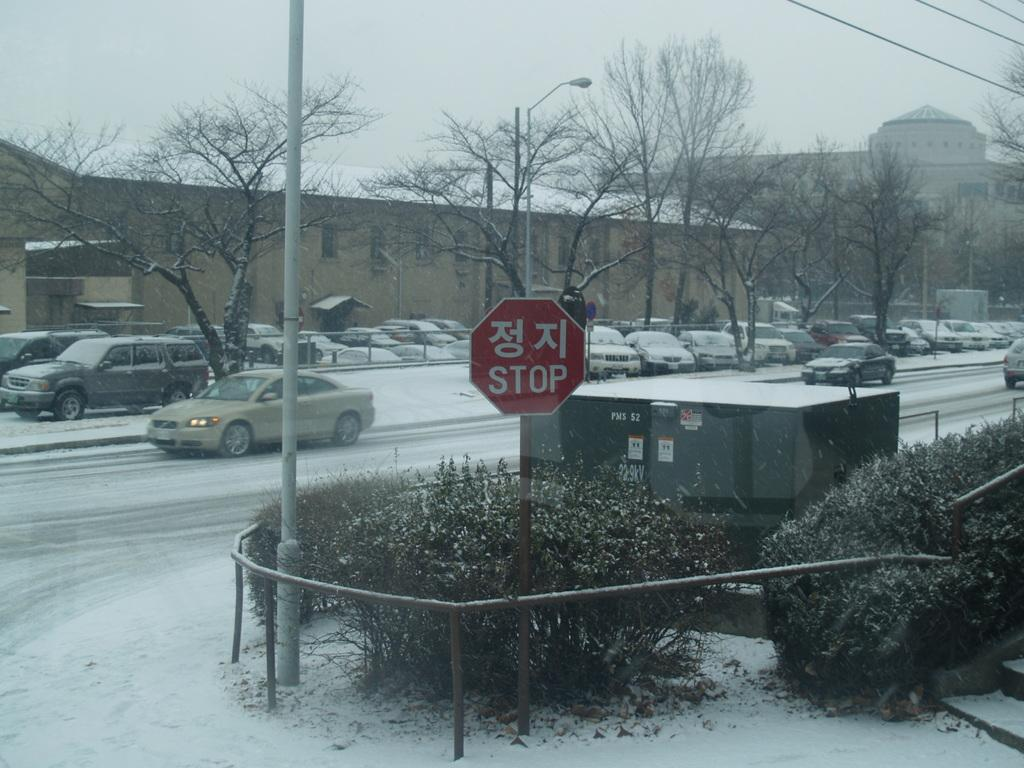What is happening on the road in the image? Vehicles are moving on the road in the image. Are there any vehicles not moving in the image? Yes, some vehicles are parked at the side of the road. What can be seen in the background of the image? There are buildings visible in the image. What is the condition of the trees in the image? The trees are fully covered with snow. Can you see a boat navigating through the snow-covered trees in the image? No, there is no boat visible in the image, and the trees are not navigable due to the snow coverage. 